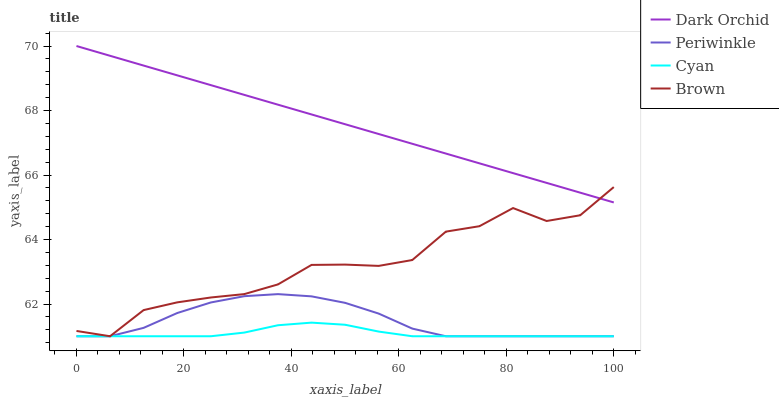Does Cyan have the minimum area under the curve?
Answer yes or no. Yes. Does Dark Orchid have the maximum area under the curve?
Answer yes or no. Yes. Does Periwinkle have the minimum area under the curve?
Answer yes or no. No. Does Periwinkle have the maximum area under the curve?
Answer yes or no. No. Is Dark Orchid the smoothest?
Answer yes or no. Yes. Is Brown the roughest?
Answer yes or no. Yes. Is Periwinkle the smoothest?
Answer yes or no. No. Is Periwinkle the roughest?
Answer yes or no. No. Does Cyan have the lowest value?
Answer yes or no. Yes. Does Dark Orchid have the lowest value?
Answer yes or no. No. Does Dark Orchid have the highest value?
Answer yes or no. Yes. Does Periwinkle have the highest value?
Answer yes or no. No. Is Periwinkle less than Dark Orchid?
Answer yes or no. Yes. Is Dark Orchid greater than Periwinkle?
Answer yes or no. Yes. Does Periwinkle intersect Brown?
Answer yes or no. Yes. Is Periwinkle less than Brown?
Answer yes or no. No. Is Periwinkle greater than Brown?
Answer yes or no. No. Does Periwinkle intersect Dark Orchid?
Answer yes or no. No. 